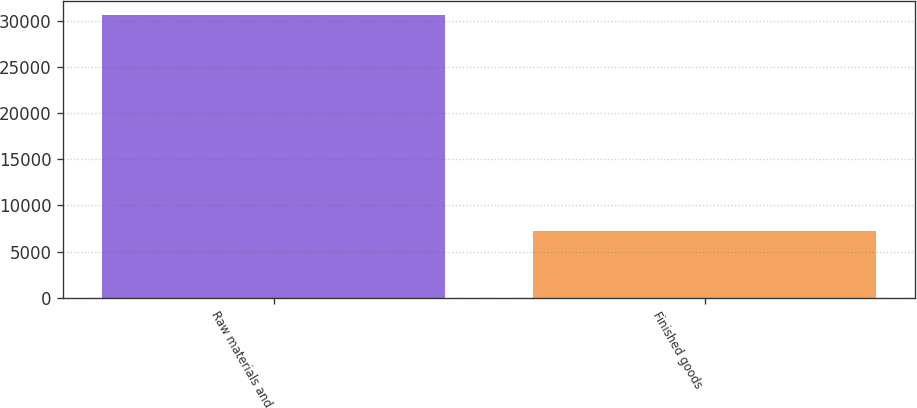Convert chart to OTSL. <chart><loc_0><loc_0><loc_500><loc_500><bar_chart><fcel>Raw materials and<fcel>Finished goods<nl><fcel>30637<fcel>7218<nl></chart> 